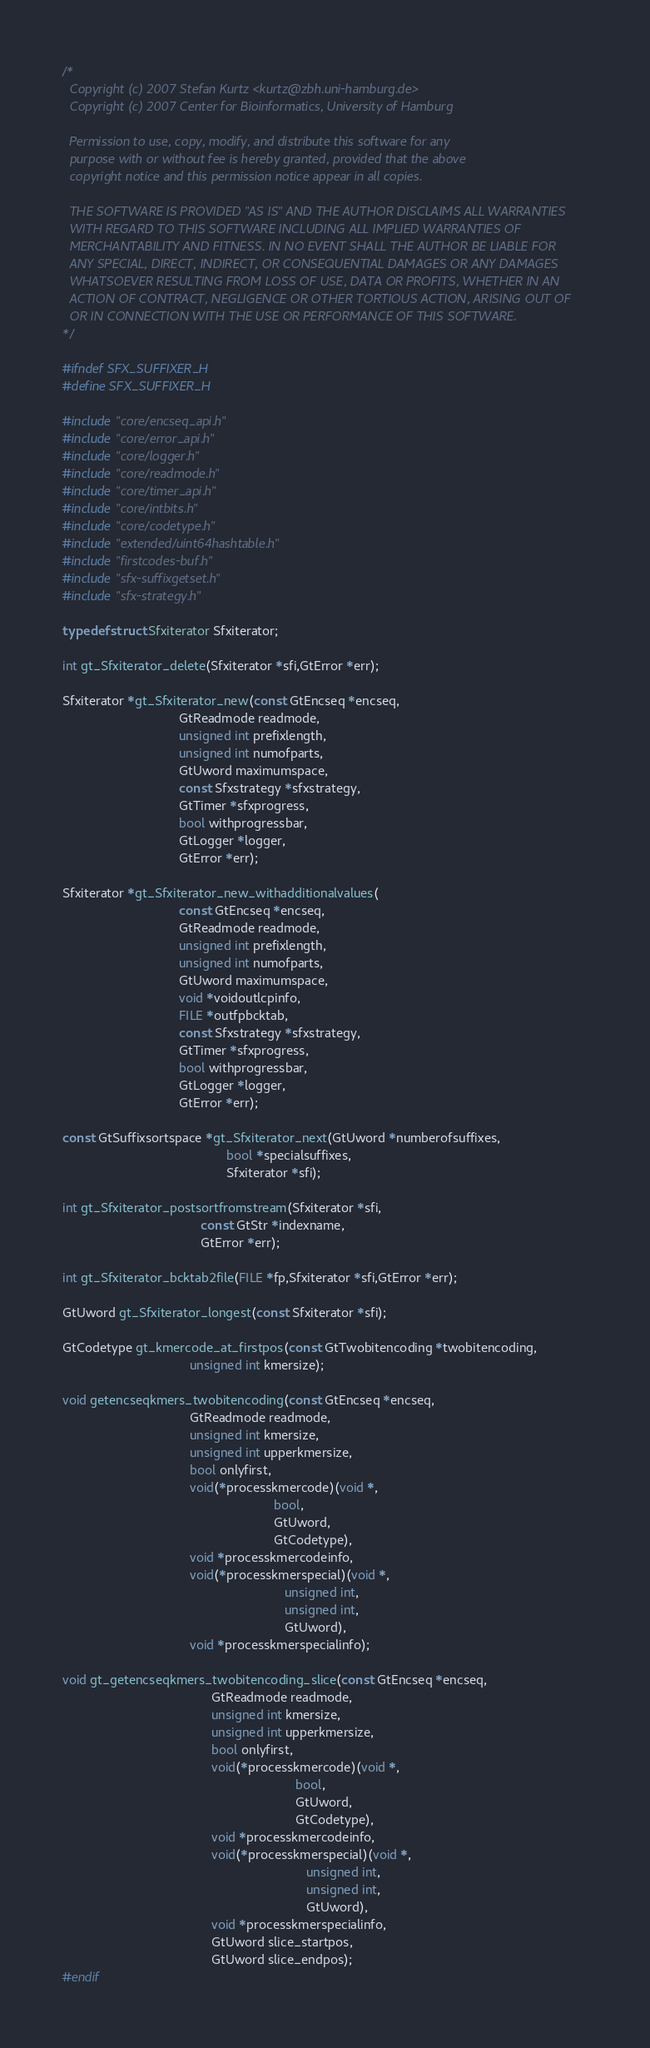<code> <loc_0><loc_0><loc_500><loc_500><_C_>/*
  Copyright (c) 2007 Stefan Kurtz <kurtz@zbh.uni-hamburg.de>
  Copyright (c) 2007 Center for Bioinformatics, University of Hamburg

  Permission to use, copy, modify, and distribute this software for any
  purpose with or without fee is hereby granted, provided that the above
  copyright notice and this permission notice appear in all copies.

  THE SOFTWARE IS PROVIDED "AS IS" AND THE AUTHOR DISCLAIMS ALL WARRANTIES
  WITH REGARD TO THIS SOFTWARE INCLUDING ALL IMPLIED WARRANTIES OF
  MERCHANTABILITY AND FITNESS. IN NO EVENT SHALL THE AUTHOR BE LIABLE FOR
  ANY SPECIAL, DIRECT, INDIRECT, OR CONSEQUENTIAL DAMAGES OR ANY DAMAGES
  WHATSOEVER RESULTING FROM LOSS OF USE, DATA OR PROFITS, WHETHER IN AN
  ACTION OF CONTRACT, NEGLIGENCE OR OTHER TORTIOUS ACTION, ARISING OUT OF
  OR IN CONNECTION WITH THE USE OR PERFORMANCE OF THIS SOFTWARE.
*/

#ifndef SFX_SUFFIXER_H
#define SFX_SUFFIXER_H

#include "core/encseq_api.h"
#include "core/error_api.h"
#include "core/logger.h"
#include "core/readmode.h"
#include "core/timer_api.h"
#include "core/intbits.h"
#include "core/codetype.h"
#include "extended/uint64hashtable.h"
#include "firstcodes-buf.h"
#include "sfx-suffixgetset.h"
#include "sfx-strategy.h"

typedef struct Sfxiterator Sfxiterator;

int gt_Sfxiterator_delete(Sfxiterator *sfi,GtError *err);

Sfxiterator *gt_Sfxiterator_new(const GtEncseq *encseq,
                                GtReadmode readmode,
                                unsigned int prefixlength,
                                unsigned int numofparts,
                                GtUword maximumspace,
                                const Sfxstrategy *sfxstrategy,
                                GtTimer *sfxprogress,
                                bool withprogressbar,
                                GtLogger *logger,
                                GtError *err);

Sfxiterator *gt_Sfxiterator_new_withadditionalvalues(
                                const GtEncseq *encseq,
                                GtReadmode readmode,
                                unsigned int prefixlength,
                                unsigned int numofparts,
                                GtUword maximumspace,
                                void *voidoutlcpinfo,
                                FILE *outfpbcktab,
                                const Sfxstrategy *sfxstrategy,
                                GtTimer *sfxprogress,
                                bool withprogressbar,
                                GtLogger *logger,
                                GtError *err);

const GtSuffixsortspace *gt_Sfxiterator_next(GtUword *numberofsuffixes,
                                             bool *specialsuffixes,
                                             Sfxiterator *sfi);

int gt_Sfxiterator_postsortfromstream(Sfxiterator *sfi,
                                      const GtStr *indexname,
                                      GtError *err);

int gt_Sfxiterator_bcktab2file(FILE *fp,Sfxiterator *sfi,GtError *err);

GtUword gt_Sfxiterator_longest(const Sfxiterator *sfi);

GtCodetype gt_kmercode_at_firstpos(const GtTwobitencoding *twobitencoding,
                                   unsigned int kmersize);

void getencseqkmers_twobitencoding(const GtEncseq *encseq,
                                   GtReadmode readmode,
                                   unsigned int kmersize,
                                   unsigned int upperkmersize,
                                   bool onlyfirst,
                                   void(*processkmercode)(void *,
                                                          bool,
                                                          GtUword,
                                                          GtCodetype),
                                   void *processkmercodeinfo,
                                   void(*processkmerspecial)(void *,
                                                             unsigned int,
                                                             unsigned int,
                                                             GtUword),
                                   void *processkmerspecialinfo);

void gt_getencseqkmers_twobitencoding_slice(const GtEncseq *encseq,
                                         GtReadmode readmode,
                                         unsigned int kmersize,
                                         unsigned int upperkmersize,
                                         bool onlyfirst,
                                         void(*processkmercode)(void *,
                                                                bool,
                                                                GtUword,
                                                                GtCodetype),
                                         void *processkmercodeinfo,
                                         void(*processkmerspecial)(void *,
                                                                   unsigned int,
                                                                   unsigned int,
                                                                   GtUword),
                                         void *processkmerspecialinfo,
                                         GtUword slice_startpos,
                                         GtUword slice_endpos);
#endif
</code> 